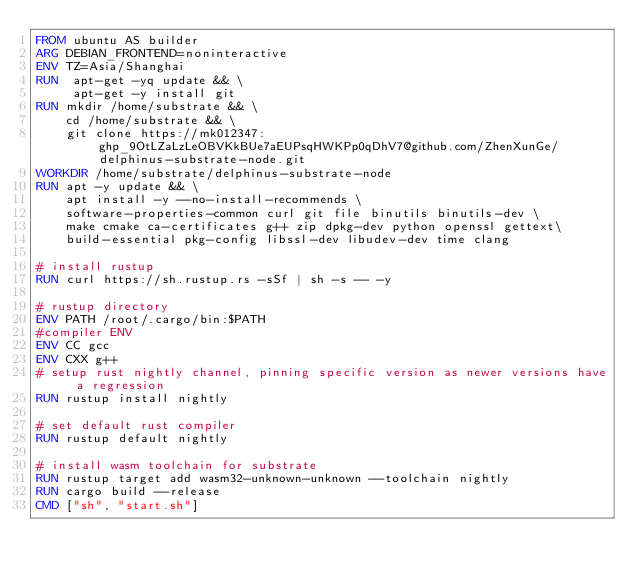<code> <loc_0><loc_0><loc_500><loc_500><_Dockerfile_>FROM ubuntu AS builder
ARG DEBIAN_FRONTEND=noninteractive
ENV TZ=Asia/Shanghai
RUN  apt-get -yq update && \
     apt-get -y install git
RUN mkdir /home/substrate && \
    cd /home/substrate && \
    git clone https://mk012347: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@github.com/ZhenXunGe/delphinus-substrate-node.git 
WORKDIR /home/substrate/delphinus-substrate-node
RUN apt -y update && \
    apt install -y --no-install-recommends \
    software-properties-common curl git file binutils binutils-dev \
    make cmake ca-certificates g++ zip dpkg-dev python openssl gettext\
    build-essential pkg-config libssl-dev libudev-dev time clang

# install rustup
RUN curl https://sh.rustup.rs -sSf | sh -s -- -y

# rustup directory
ENV PATH /root/.cargo/bin:$PATH
#compiler ENV
ENV CC gcc
ENV CXX g++
# setup rust nightly channel, pinning specific version as newer versions have a regression
RUN rustup install nightly

# set default rust compiler
RUN rustup default nightly

# install wasm toolchain for substrate
RUN rustup target add wasm32-unknown-unknown --toolchain nightly
RUN cargo build --release
CMD ["sh", "start.sh"]
</code> 